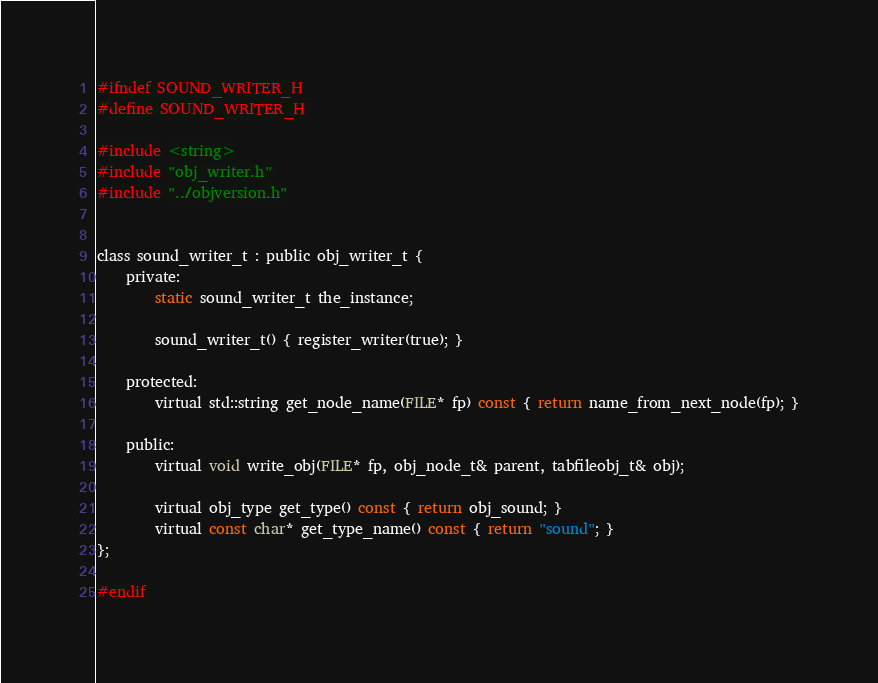Convert code to text. <code><loc_0><loc_0><loc_500><loc_500><_C_>#ifndef SOUND_WRITER_H
#define SOUND_WRITER_H

#include <string>
#include "obj_writer.h"
#include "../objversion.h"


class sound_writer_t : public obj_writer_t {
	private:
		static sound_writer_t the_instance;

		sound_writer_t() { register_writer(true); }

	protected:
		virtual std::string get_node_name(FILE* fp) const { return name_from_next_node(fp); }

	public:
		virtual void write_obj(FILE* fp, obj_node_t& parent, tabfileobj_t& obj);

		virtual obj_type get_type() const { return obj_sound; }
		virtual const char* get_type_name() const { return "sound"; }
};

#endif
</code> 